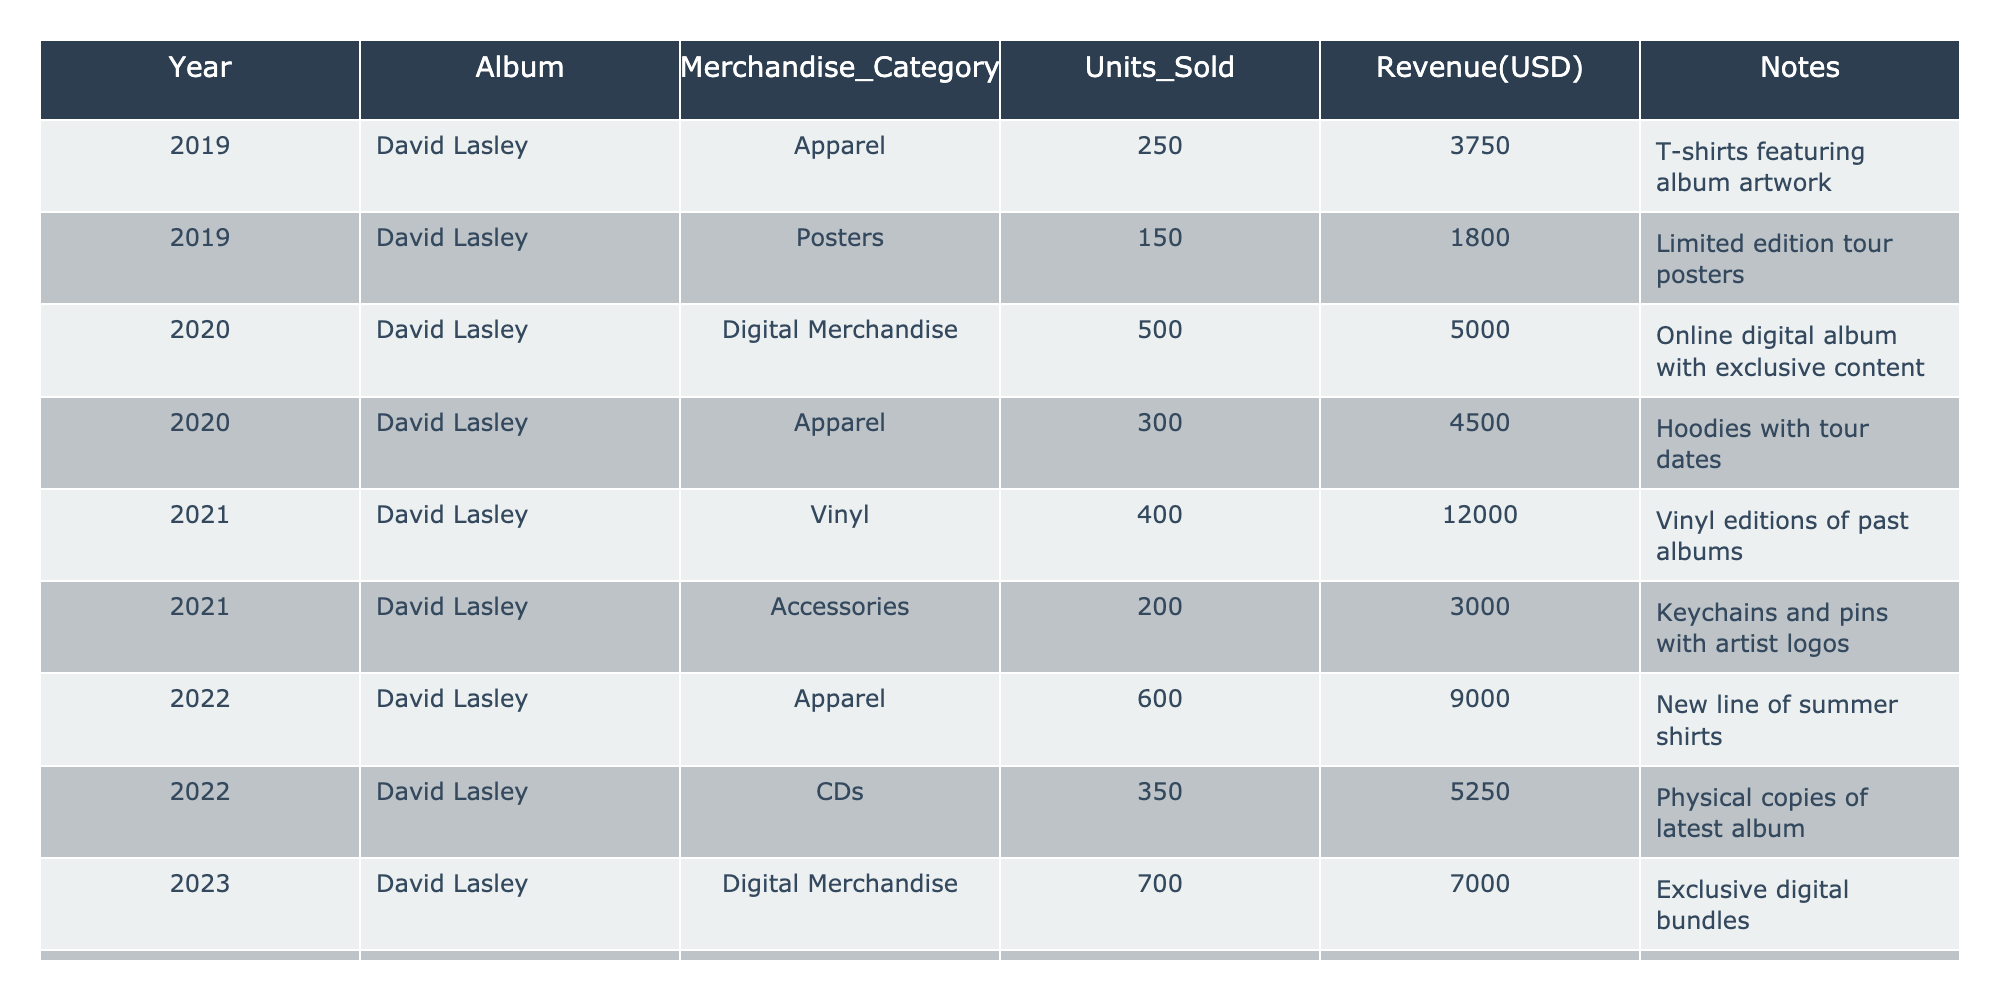What was the total revenue from apparel sales over the five years? From the table: 2019: $3750, 2020: $4500, 2022: $9000. Therefore, the total revenue for apparel is $3750 + $4500 + $9000 = $17250.
Answer: $17250 Which year had the highest units sold in digital merchandise? In the table, the units sold for digital merchandise are: 2020: 500, 2023: 700. Since 700 is greater than 500, the highest units sold were in 2023.
Answer: 2023 Did merchandise sales increase or decrease from 2021 to 2022? In 2021, total revenue for all merchandise sales was $15000 (Vinyl + Accessories); in 2022, total revenue was $14250 (Apparel + CDs). Therefore, there was a decrease from 2021 to 2022.
Answer: Decrease What was the percentage increase in revenue from 2022 to 2023? Revenue for 2022 is $14250 and for 2023 is $13500. The increase is $13500 - $14250 = -$750. The percentage change is (-750 / 14250) * 100 = -5.26%.
Answer: -5.26% Which merchandise category had the highest sales in 2021? In 2021, the categories were 400 units of Vinyl ($12000) and 200 units of Accessories ($3000). Vinyl sales were the highest at $12000.
Answer: Vinyl How many units of accessories were sold in total over the five years? The totals are: 2021: 200 units, 2023: 450 units. Therefore, total accessories sold are 200 + 450 = 650 units.
Answer: 650 units What was the average revenue per year for the merchandise categories listed? The total revenue over the five years is $3750 + $1800 + $5000 + $4500 + $12000 + $3000 + $9000 + $5250 + $7000 + $6750 = $48450. Dividing this by 5 years gives $9690.
Answer: $9690 Did digital merchandise see a rise in units sold on the last two years compared to the first two years? Units sold for digital merchandise in first two years (2020) is 500, and the last two years (2023) is 700. Comparing these, digital merchandise units increased from 500 to 700.
Answer: Yes What percentage of the total revenue in 2022 came from apparel? Total revenue in 2022 was $14250, and revenue from apparel was $9000. The percentage is ($9000 / $14250) * 100 = 63.16%.
Answer: 63.16% Which year had the lowest merchandise sales in terms of units sold? The units sold are: 2019: 400, 2020: 800, 2021: 600, 2022: 950, 2023: 1150. The lowest sales year is 2019 with 400 units sold.
Answer: 2019 